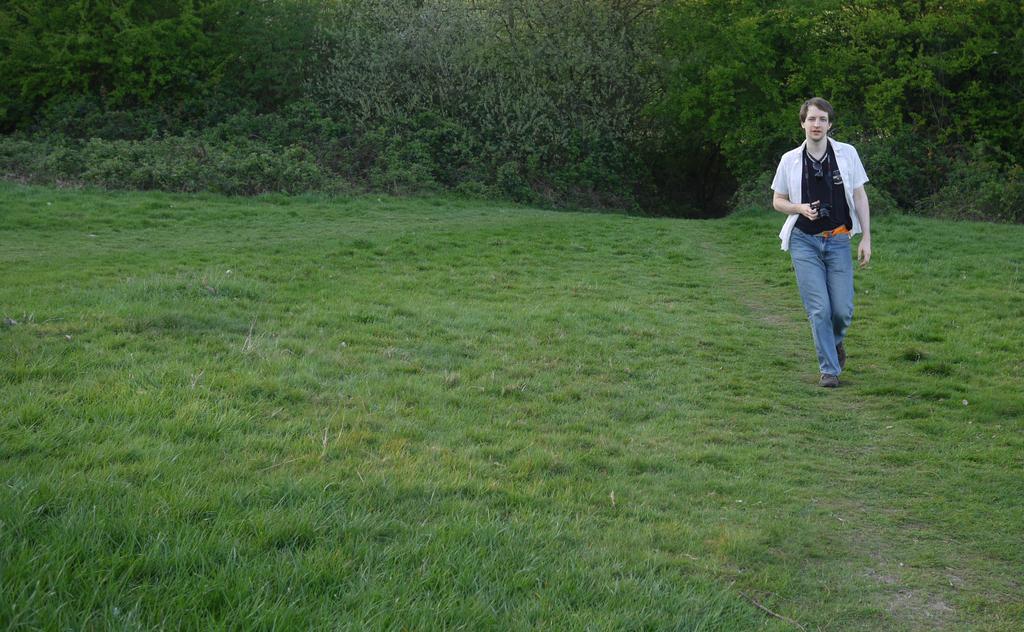Can you describe this image briefly? In this picture I can see a person is walking on the ground. The person is wearing white color shirt and blue jeans. Here I can see trees and grass. 